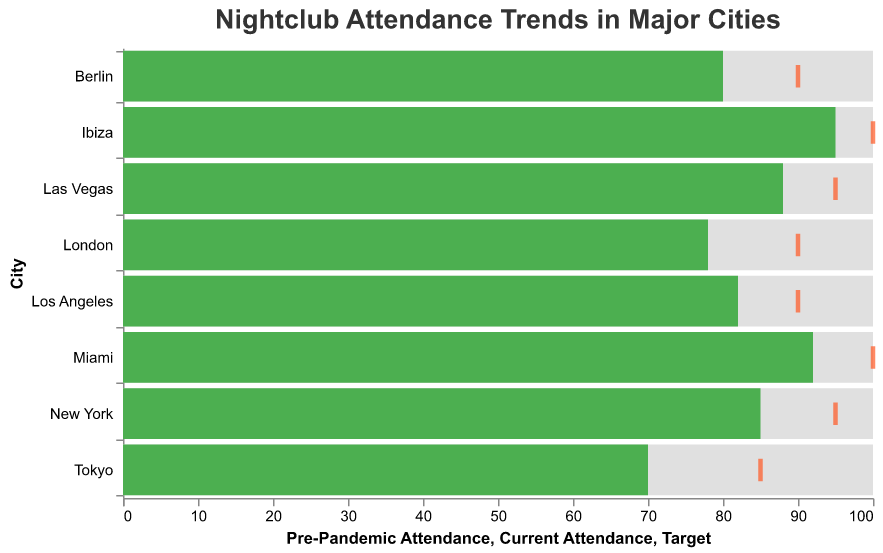What's the average current attendance in all major cities? To calculate the average current attendance, sum up the attendance numbers for all cities and then divide by the number of cities. The sum is 85 (New York) + 78 (London) + 92 (Miami) + 88 (Las Vegas) + 80 (Berlin) + 95 (Ibiza) + 70 (Tokyo) + 82 (Los Angeles) = 670. Since there are 8 cities, the average is 670 / 8.
Answer: 83.75 Which city has the highest current attendance? By looking at the 'Current Attendance' bar for each city, Ibiza has the highest value at 95.
Answer: Ibiza How many cities are meeting or exceeding their target attendance? From the figure, compare the 'Current Attendance' bars to the 'Target' ticks. Miami and Ibiza have current attendance equal to their target, making a total of 2 cities.
Answer: 2 What is the gap between current attendance and target attendance for Tokyo? The 'Current Attendance' for Tokyo is 70 and the 'Target' is 85. The gap is calculated as 85 - 70.
Answer: 15 Which city has the largest gap between pre-pandemic and current attendance levels? By comparing the 'Pre-Pandemic Attendance' and 'Current Attendance' bars, London shows the largest gap of 100 - 78.
Answer: London What's the difference between the current attendance and the target for New York? The 'Current Attendance' for New York is 85 and the 'Target' is 95. The difference is 95 - 85.
Answer: 10 Which city has the smallest difference between current attendance and pre-pandemic levels? By checking the difference for all cities, Ibiza has the smallest difference since its current attendance is 95 and pre-pandemic level is 100, making the difference 100 - 95.
Answer: Ibiza Are there any cities where current attendance is higher than the target? None of the 'Current Attendance' bars exceed the 'Target' ticks.
Answer: No What's the average gap between current and target attendance for all cities? First, calculate the gaps for each city: New York (10), London (12), Miami (8), Las Vegas (7), Berlin (10), Ibiza (5), Tokyo (15), Los Angeles (8). Sum these gaps: 10 + 12 + 8 + 7 + 10 + 5 + 15 + 8 = 75. The average gap is 75 / 8.
Answer: 9.375 